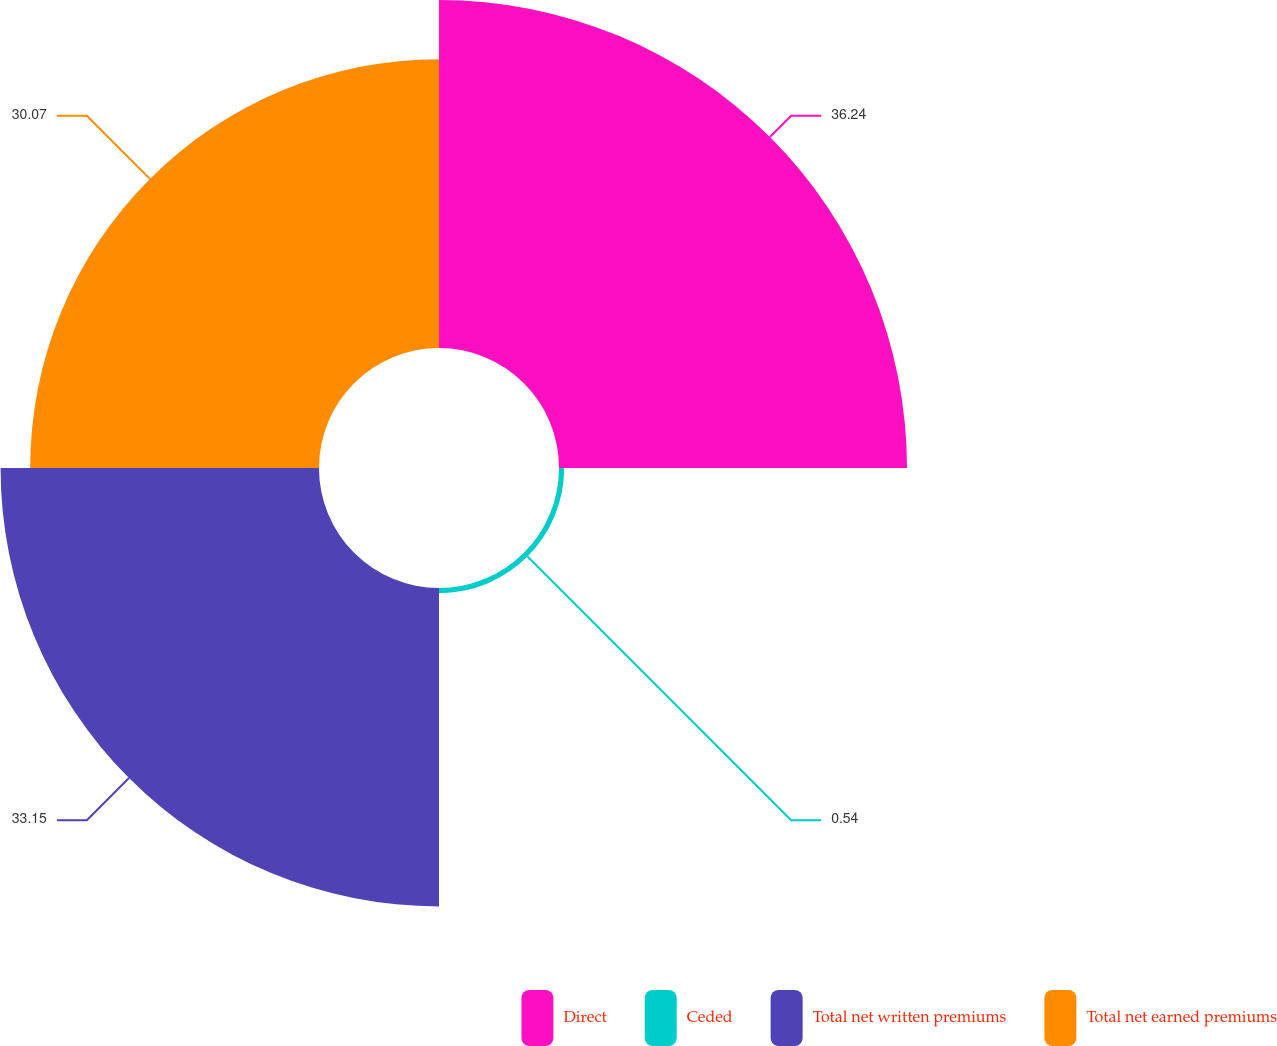<chart> <loc_0><loc_0><loc_500><loc_500><pie_chart><fcel>Direct<fcel>Ceded<fcel>Total net written premiums<fcel>Total net earned premiums<nl><fcel>36.23%<fcel>0.54%<fcel>33.15%<fcel>30.07%<nl></chart> 